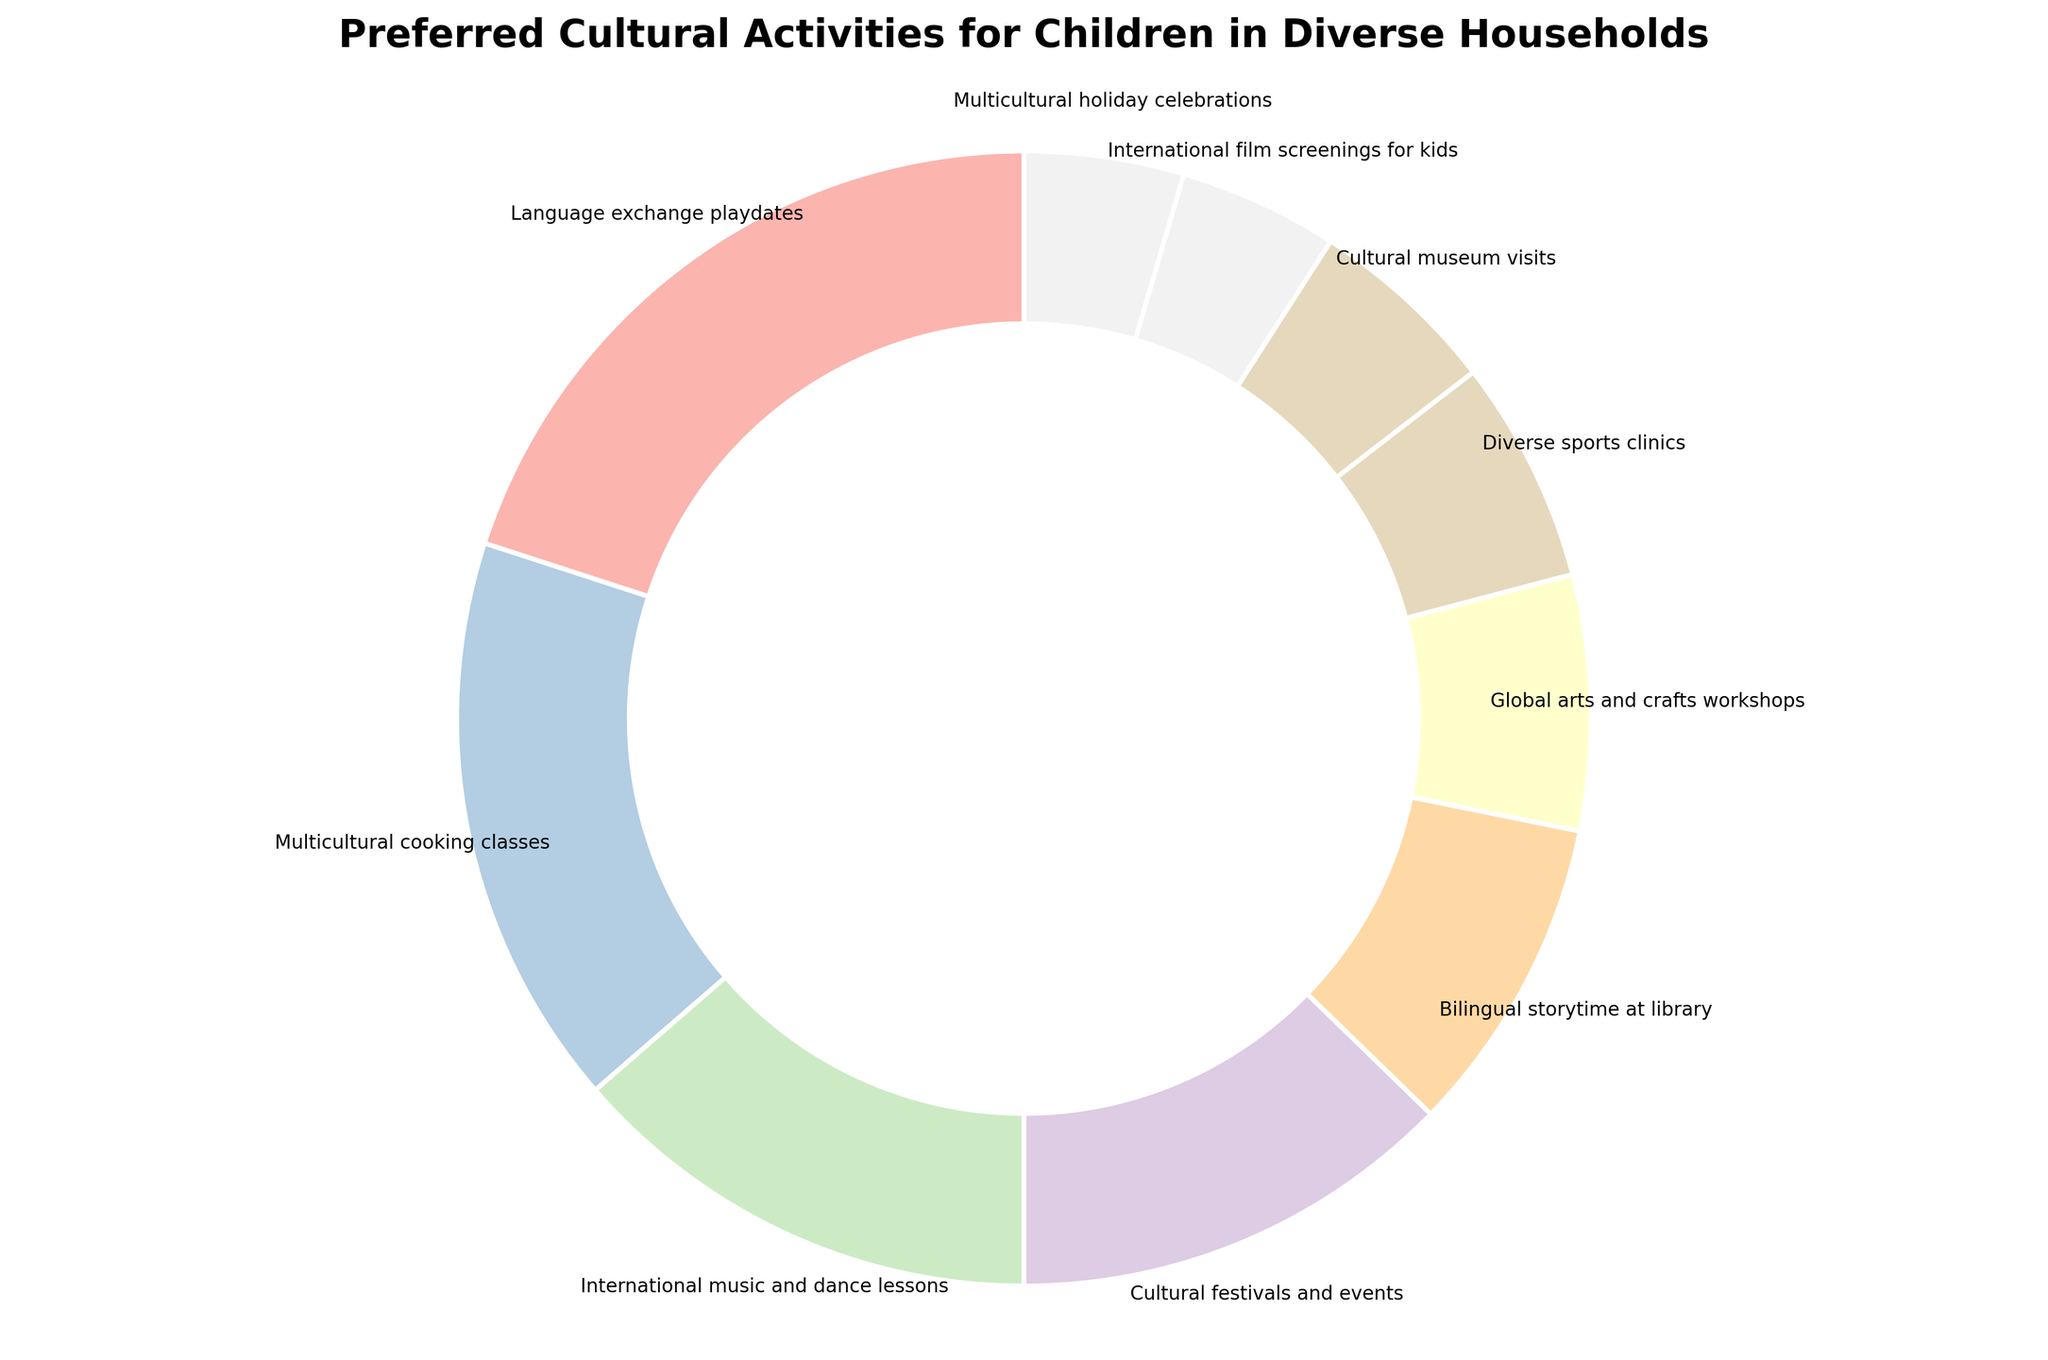What is the most preferred cultural activity for children in diverse households? The pie chart shows various cultural activities with their respective percentages. The largest segment represents "Language exchange playdates" at 22%, indicating it is the most preferred activity.
Answer: Language exchange playdates Which cultural activity is preferred less than Global arts and crafts workshops? To find the activity preferred less than Global arts and crafts workshops, look for segments with percentages lower than 8%. The activities are Diverse sports clinics (7%), Cultural museum visits (6%), International film screenings for kids (5%), and Multicultural holiday celebrations (5%).
Answer: Diverse sports clinics, Cultural museum visits, International film screenings for kids, Multicultural holiday celebrations What is the combined preference for International music and dance lessons and Cultural festivals and events? International music and dance lessons have a percentage of 15%, and Cultural festivals and events have 14%. Adding these gives: 15% + 14% = 29%.
Answer: 29% Which activity has a higher preference, Bilingual storytime at library or Multicultural cooking classes? Bilingual storytime at library has a preference of 10%, while Multicultural cooking classes have a preference of 18%. Comparing these two, 18% is higher than 10%.
Answer: Multicultural cooking classes How does the preference for Multicultural holiday celebrations compare to International film screenings for kids? Both Multicultural holiday celebrations and International film screenings for kids have a preference of 5%, so their preference is equal.
Answer: Equal What are the three activities with the lowest preference percentages? To determine the three activities with the lowest preference, look for the smallest segments. These are International film screenings for kids (5%), Multicultural holiday celebrations (5%), and Cultural museum visits (6%).
Answer: International film screenings for kids, Multicultural holiday celebrations, Cultural museum visits What is the difference in preference between Language exchange playdates and Diverse sports clinics? Language exchange playdates have a preference of 22%, while Diverse sports clinics have 7%. The difference is 22% - 7% = 15%.
Answer: 15% Are there more activities with a preference below 10% or above 10%? Activities below 10%: Global arts and crafts workshops (8%), Diverse sports clinics (7%), Cultural museum visits (6%), International film screenings for kids (5%), Multicultural holiday celebrations (5%). 
Activities above 10%: Language exchange playdates (22%), Multicultural cooking classes (18%), International music and dance lessons (15%), Cultural festivals and events (14%), Bilingual storytime at library (10%).
Count: below 10% = 5, above 10% = 5.
Answer: Equal number What is the total preference percentage for activities that include arts and crafts? The only activity that includes "arts and crafts" explicitly is Global arts and crafts workshops at 8%.
Answer: 8% 